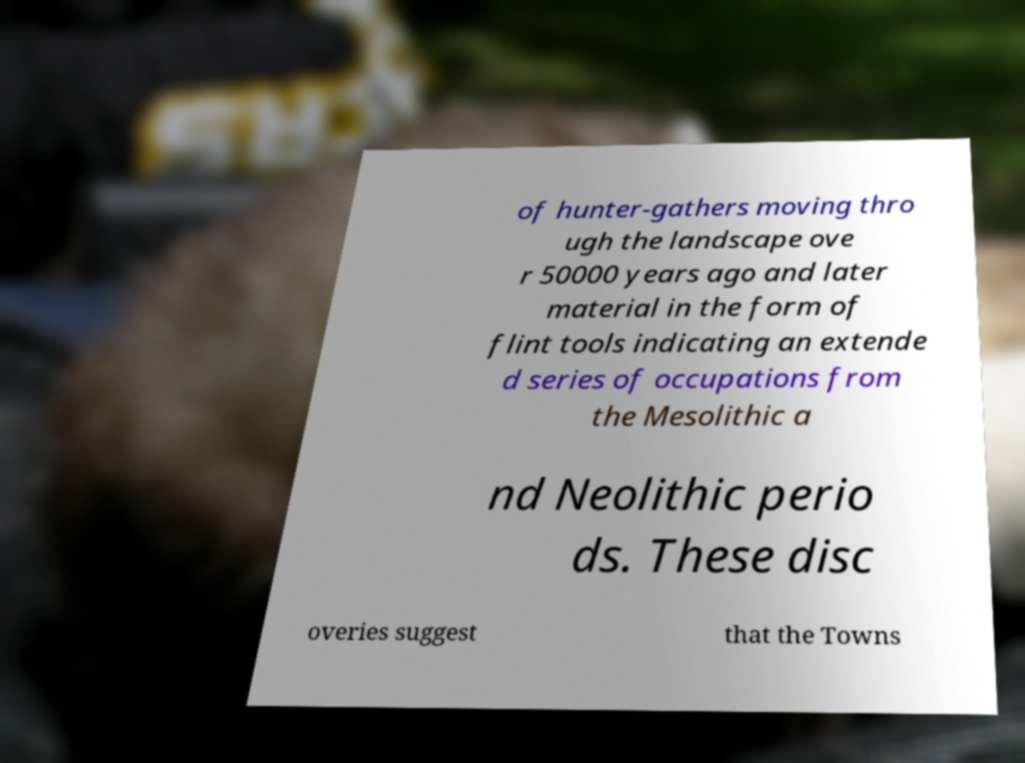Can you accurately transcribe the text from the provided image for me? of hunter-gathers moving thro ugh the landscape ove r 50000 years ago and later material in the form of flint tools indicating an extende d series of occupations from the Mesolithic a nd Neolithic perio ds. These disc overies suggest that the Towns 